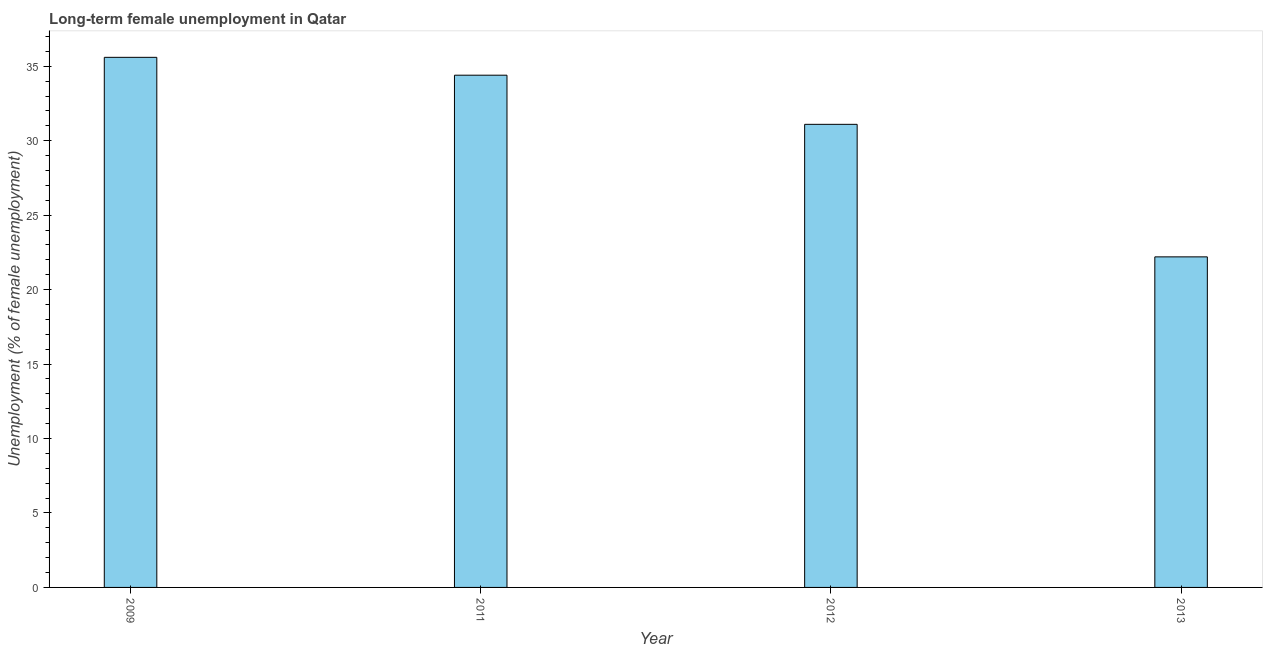What is the title of the graph?
Keep it short and to the point. Long-term female unemployment in Qatar. What is the label or title of the X-axis?
Provide a succinct answer. Year. What is the label or title of the Y-axis?
Your answer should be very brief. Unemployment (% of female unemployment). What is the long-term female unemployment in 2013?
Make the answer very short. 22.2. Across all years, what is the maximum long-term female unemployment?
Your response must be concise. 35.6. Across all years, what is the minimum long-term female unemployment?
Your answer should be compact. 22.2. In which year was the long-term female unemployment minimum?
Your answer should be very brief. 2013. What is the sum of the long-term female unemployment?
Your answer should be compact. 123.3. What is the difference between the long-term female unemployment in 2009 and 2013?
Your answer should be compact. 13.4. What is the average long-term female unemployment per year?
Provide a succinct answer. 30.82. What is the median long-term female unemployment?
Your answer should be compact. 32.75. In how many years, is the long-term female unemployment greater than 6 %?
Make the answer very short. 4. What is the ratio of the long-term female unemployment in 2012 to that in 2013?
Keep it short and to the point. 1.4. Is the difference between the long-term female unemployment in 2009 and 2011 greater than the difference between any two years?
Your answer should be compact. No. What is the difference between the highest and the second highest long-term female unemployment?
Offer a very short reply. 1.2. Is the sum of the long-term female unemployment in 2009 and 2011 greater than the maximum long-term female unemployment across all years?
Your response must be concise. Yes. What is the difference between the highest and the lowest long-term female unemployment?
Give a very brief answer. 13.4. In how many years, is the long-term female unemployment greater than the average long-term female unemployment taken over all years?
Provide a succinct answer. 3. How many bars are there?
Offer a terse response. 4. Are all the bars in the graph horizontal?
Make the answer very short. No. What is the Unemployment (% of female unemployment) of 2009?
Provide a succinct answer. 35.6. What is the Unemployment (% of female unemployment) of 2011?
Provide a succinct answer. 34.4. What is the Unemployment (% of female unemployment) of 2012?
Your response must be concise. 31.1. What is the Unemployment (% of female unemployment) of 2013?
Provide a succinct answer. 22.2. What is the difference between the Unemployment (% of female unemployment) in 2009 and 2013?
Give a very brief answer. 13.4. What is the ratio of the Unemployment (% of female unemployment) in 2009 to that in 2011?
Your answer should be compact. 1.03. What is the ratio of the Unemployment (% of female unemployment) in 2009 to that in 2012?
Give a very brief answer. 1.15. What is the ratio of the Unemployment (% of female unemployment) in 2009 to that in 2013?
Make the answer very short. 1.6. What is the ratio of the Unemployment (% of female unemployment) in 2011 to that in 2012?
Ensure brevity in your answer.  1.11. What is the ratio of the Unemployment (% of female unemployment) in 2011 to that in 2013?
Give a very brief answer. 1.55. What is the ratio of the Unemployment (% of female unemployment) in 2012 to that in 2013?
Provide a succinct answer. 1.4. 